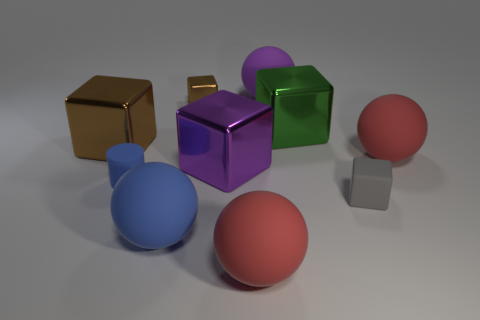How many things are either red balls that are in front of the large blue rubber object or green rubber cylinders?
Ensure brevity in your answer.  1. There is a big purple thing that is on the left side of the big sphere that is behind the red matte ball behind the blue rubber cylinder; what is it made of?
Keep it short and to the point. Metal. Is the number of big red spheres that are in front of the gray matte object greater than the number of large purple matte spheres that are in front of the blue matte ball?
Give a very brief answer. Yes. How many spheres are either tiny gray things or metal things?
Provide a succinct answer. 0. What number of large purple rubber things are behind the red matte ball behind the red ball that is in front of the purple shiny thing?
Ensure brevity in your answer.  1. What material is the big sphere that is the same color as the cylinder?
Provide a short and direct response. Rubber. Are there more gray rubber things than tiny brown spheres?
Give a very brief answer. Yes. Do the green metal block and the blue matte cylinder have the same size?
Make the answer very short. No. What number of objects are gray metal balls or big brown metallic blocks?
Provide a short and direct response. 1. The tiny thing on the right side of the large block behind the brown metallic block that is left of the small brown block is what shape?
Your response must be concise. Cube. 